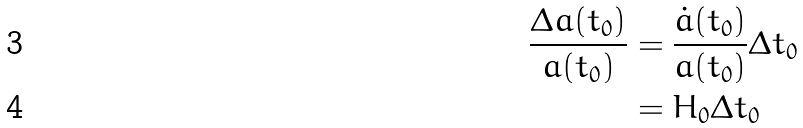Convert formula to latex. <formula><loc_0><loc_0><loc_500><loc_500>\frac { \Delta a ( t _ { 0 } ) } { a ( t _ { 0 } ) } & = \frac { \dot { a } ( t _ { 0 } ) } { a ( t _ { 0 } ) } \Delta t _ { 0 } \\ & = H _ { 0 } \Delta t _ { 0 }</formula> 